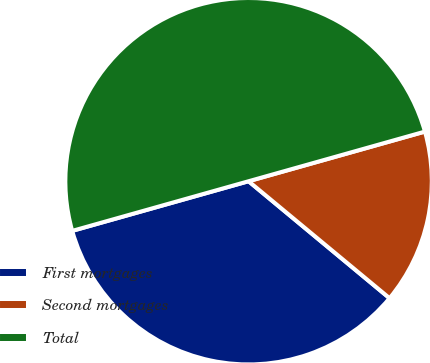<chart> <loc_0><loc_0><loc_500><loc_500><pie_chart><fcel>First mortgages<fcel>Second mortgages<fcel>Total<nl><fcel>34.61%<fcel>15.39%<fcel>50.0%<nl></chart> 